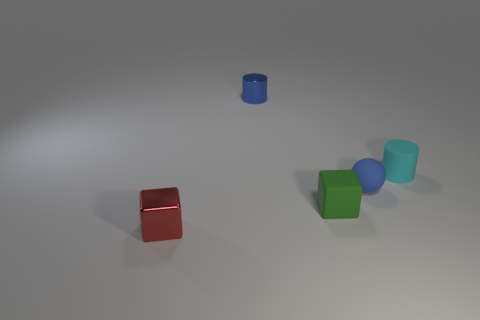Are there any blue cylinders made of the same material as the green block?
Provide a short and direct response. No. What is the material of the blue thing on the left side of the blue thing that is in front of the cyan cylinder?
Ensure brevity in your answer.  Metal. How many matte objects have the same shape as the blue shiny object?
Your answer should be compact. 1. The cyan matte thing is what shape?
Your response must be concise. Cylinder. Is the number of tiny blue metal objects less than the number of big gray metallic cubes?
Provide a short and direct response. No. What material is the tiny cyan object that is the same shape as the tiny blue metallic thing?
Your answer should be very brief. Rubber. Is the number of blue rubber things greater than the number of small brown cubes?
Your response must be concise. Yes. How many other things are there of the same color as the tiny matte ball?
Your response must be concise. 1. Is the material of the green cube the same as the tiny cylinder on the right side of the blue sphere?
Offer a very short reply. Yes. There is a cube that is left of the small shiny thing behind the small blue matte ball; what number of tiny green matte cubes are in front of it?
Give a very brief answer. 0. 